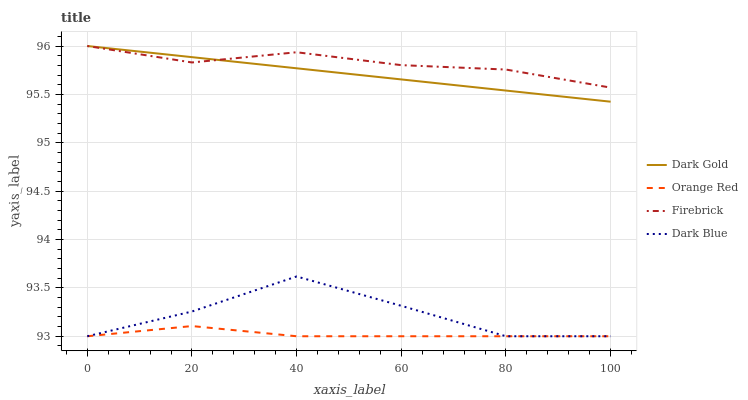Does Orange Red have the minimum area under the curve?
Answer yes or no. Yes. Does Firebrick have the maximum area under the curve?
Answer yes or no. Yes. Does Firebrick have the minimum area under the curve?
Answer yes or no. No. Does Orange Red have the maximum area under the curve?
Answer yes or no. No. Is Dark Gold the smoothest?
Answer yes or no. Yes. Is Dark Blue the roughest?
Answer yes or no. Yes. Is Firebrick the smoothest?
Answer yes or no. No. Is Firebrick the roughest?
Answer yes or no. No. Does Firebrick have the lowest value?
Answer yes or no. No. Does Dark Gold have the highest value?
Answer yes or no. Yes. Does Orange Red have the highest value?
Answer yes or no. No. Is Orange Red less than Firebrick?
Answer yes or no. Yes. Is Firebrick greater than Dark Blue?
Answer yes or no. Yes. Does Orange Red intersect Firebrick?
Answer yes or no. No. 